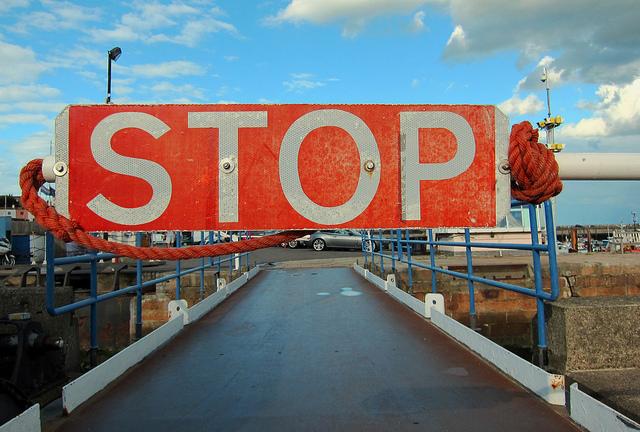What color is the rope?
Short answer required. Red. What color is the word stop written in?
Quick response, please. White. Can I walk across the bridge?
Give a very brief answer. No. 